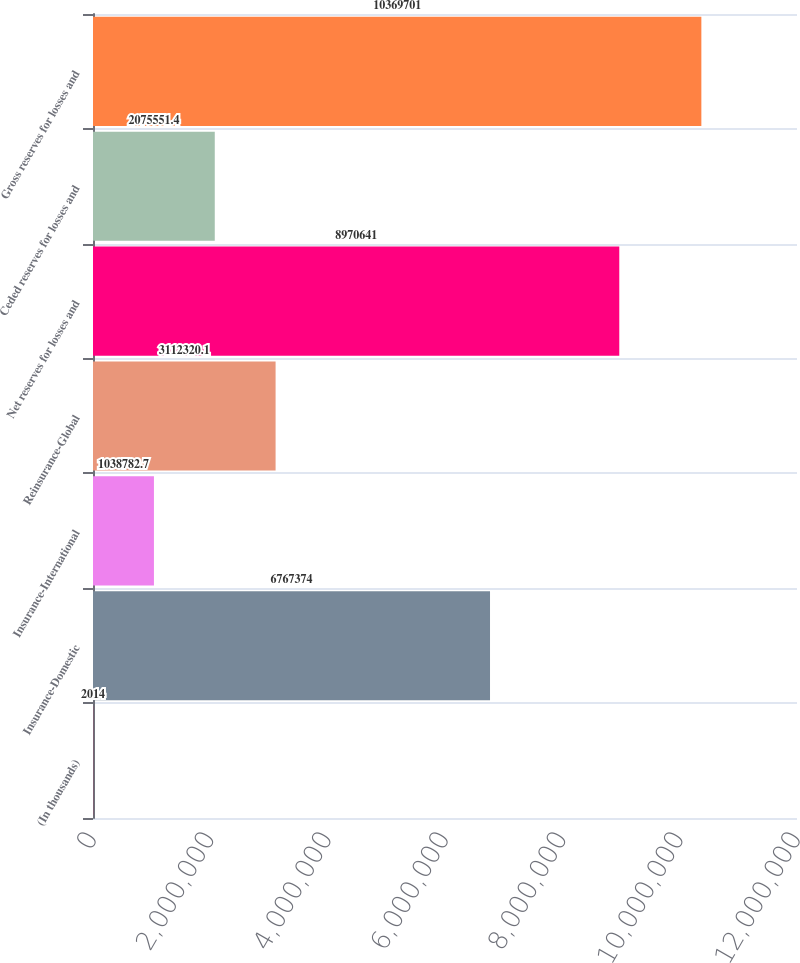Convert chart. <chart><loc_0><loc_0><loc_500><loc_500><bar_chart><fcel>(In thousands)<fcel>Insurance-Domestic<fcel>Insurance-International<fcel>Reinsurance-Global<fcel>Net reserves for losses and<fcel>Ceded reserves for losses and<fcel>Gross reserves for losses and<nl><fcel>2014<fcel>6.76737e+06<fcel>1.03878e+06<fcel>3.11232e+06<fcel>8.97064e+06<fcel>2.07555e+06<fcel>1.03697e+07<nl></chart> 